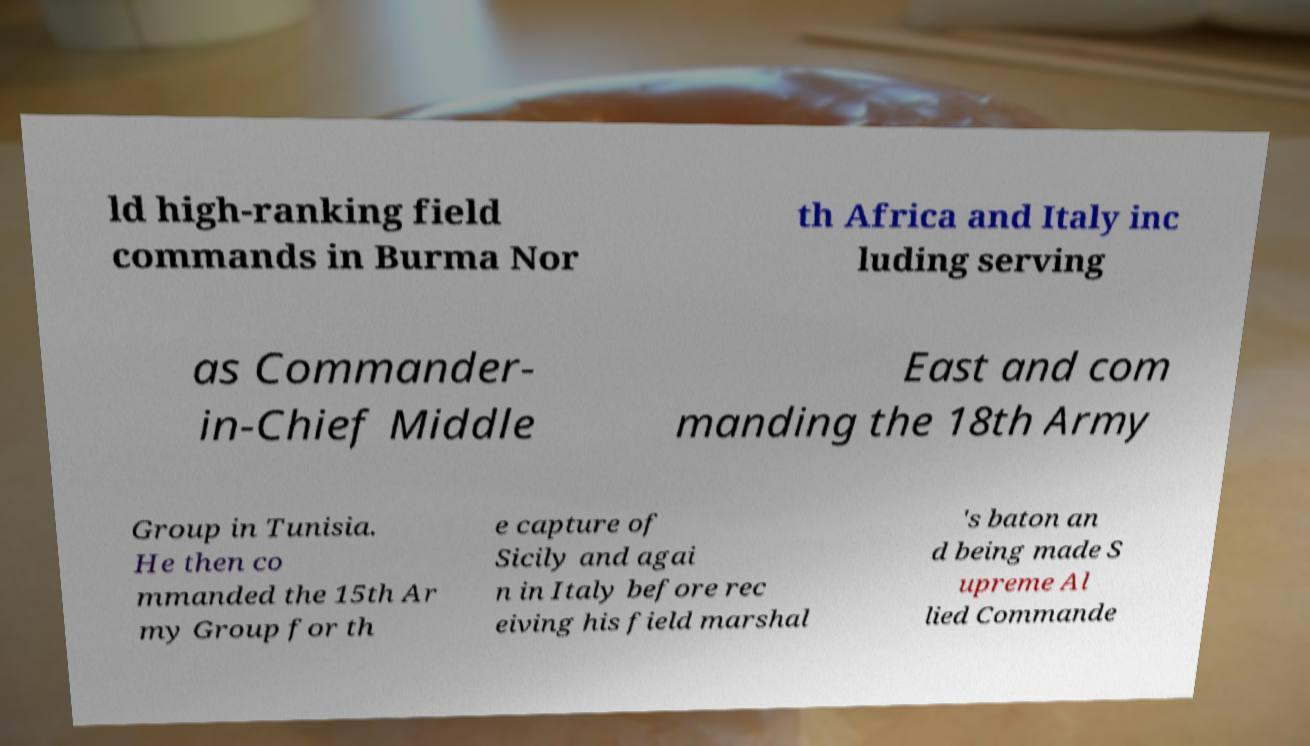Can you read and provide the text displayed in the image?This photo seems to have some interesting text. Can you extract and type it out for me? ld high-ranking field commands in Burma Nor th Africa and Italy inc luding serving as Commander- in-Chief Middle East and com manding the 18th Army Group in Tunisia. He then co mmanded the 15th Ar my Group for th e capture of Sicily and agai n in Italy before rec eiving his field marshal 's baton an d being made S upreme Al lied Commande 